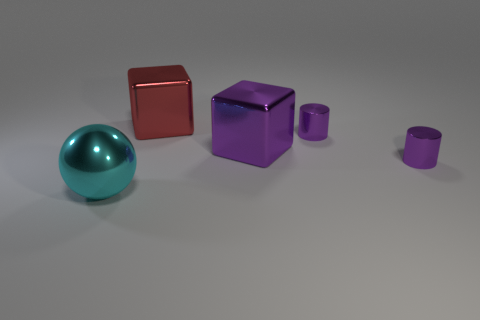Add 1 metal spheres. How many objects exist? 6 Subtract all balls. How many objects are left? 4 Subtract all large purple shiny things. Subtract all big blocks. How many objects are left? 2 Add 5 small purple cylinders. How many small purple cylinders are left? 7 Add 1 small purple shiny objects. How many small purple shiny objects exist? 3 Subtract 0 cyan cylinders. How many objects are left? 5 